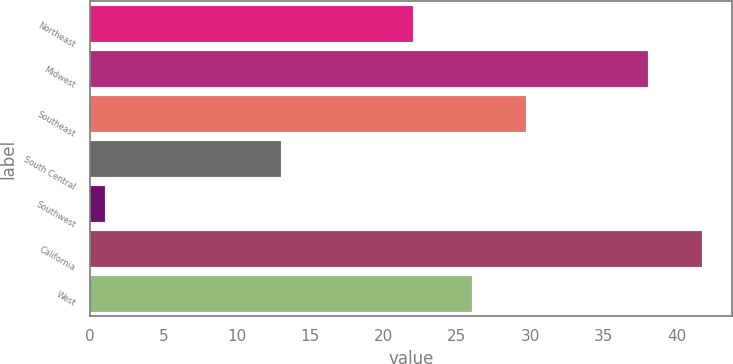Convert chart. <chart><loc_0><loc_0><loc_500><loc_500><bar_chart><fcel>Northeast<fcel>Midwest<fcel>Southeast<fcel>South Central<fcel>Southwest<fcel>California<fcel>West<nl><fcel>22<fcel>38<fcel>29.7<fcel>13<fcel>1<fcel>41.7<fcel>26<nl></chart> 